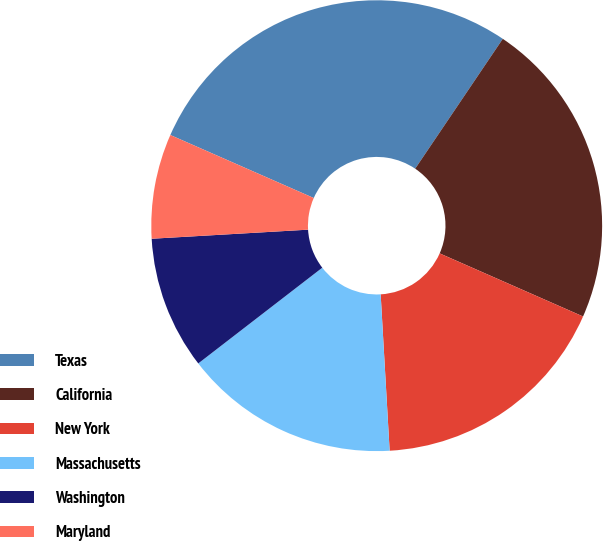Convert chart. <chart><loc_0><loc_0><loc_500><loc_500><pie_chart><fcel>Texas<fcel>California<fcel>New York<fcel>Massachusetts<fcel>Washington<fcel>Maryland<nl><fcel>27.86%<fcel>22.15%<fcel>17.49%<fcel>15.45%<fcel>9.54%<fcel>7.51%<nl></chart> 